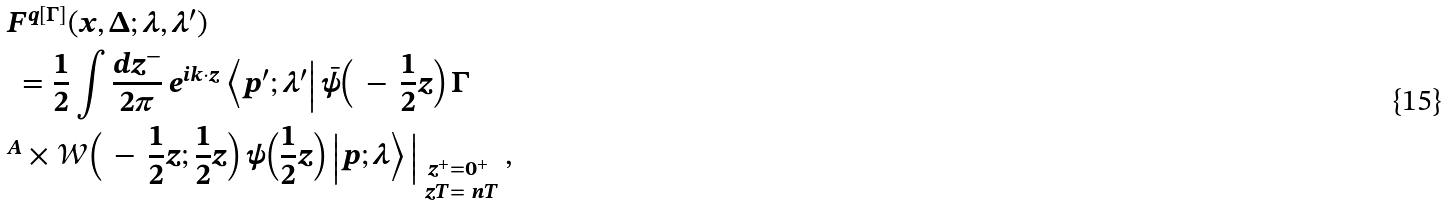<formula> <loc_0><loc_0><loc_500><loc_500>& F ^ { q [ \Gamma ] } ( x , \Delta ; \lambda , \lambda ^ { \prime } ) \\ & \ = \frac { 1 } { 2 } \int \frac { d z ^ { - } } { 2 \pi } \, e ^ { i k \cdot z } \, \Big < p ^ { \prime } ; \lambda ^ { \prime } \Big | \, \bar { \psi } \Big ( \, - \, \frac { 1 } { 2 } z \Big ) \, \Gamma \\ & ^ { A } \times \mathcal { W } \Big ( \, - \, \frac { 1 } { 2 } z ; \frac { 1 } { 2 } z \Big ) \, \psi \Big ( \frac { 1 } { 2 } z \Big ) \, \Big | p ; \lambda \Big > \, \Big | _ { \substack { z ^ { + } = 0 ^ { + } \\ \ z T = \ n T } } \, ,</formula> 